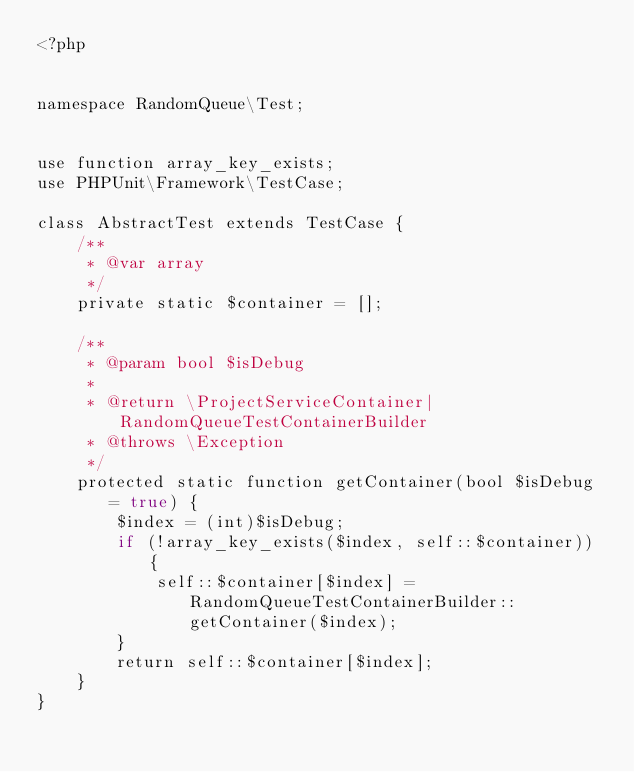Convert code to text. <code><loc_0><loc_0><loc_500><loc_500><_PHP_><?php


namespace RandomQueue\Test;


use function array_key_exists;
use PHPUnit\Framework\TestCase;

class AbstractTest extends TestCase {
    /**
     * @var array
     */
    private static $container = [];

    /**
     * @param bool $isDebug
     *
     * @return \ProjectServiceContainer|RandomQueueTestContainerBuilder
     * @throws \Exception
     */
    protected static function getContainer(bool $isDebug = true) {
        $index = (int)$isDebug;
        if (!array_key_exists($index, self::$container)) {
            self::$container[$index] = RandomQueueTestContainerBuilder::getContainer($index);
        }
        return self::$container[$index];
    }
}
</code> 